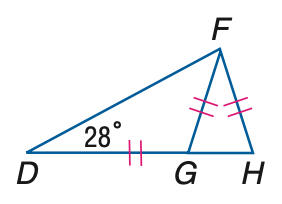Answer the mathemtical geometry problem and directly provide the correct option letter.
Question: \triangle D F G and \triangle F G H are isosceles, m \angle F D H = 28 and D G \cong F G \cong F H. Find the measure of \angle D F G.
Choices: A: 22 B: 24 C: 26 D: 28 D 